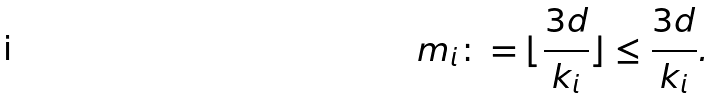<formula> <loc_0><loc_0><loc_500><loc_500>m _ { i } \colon = \lfloor \frac { 3 d } { k _ { i } } \rfloor \leq \frac { 3 d } { k _ { i } } .</formula> 